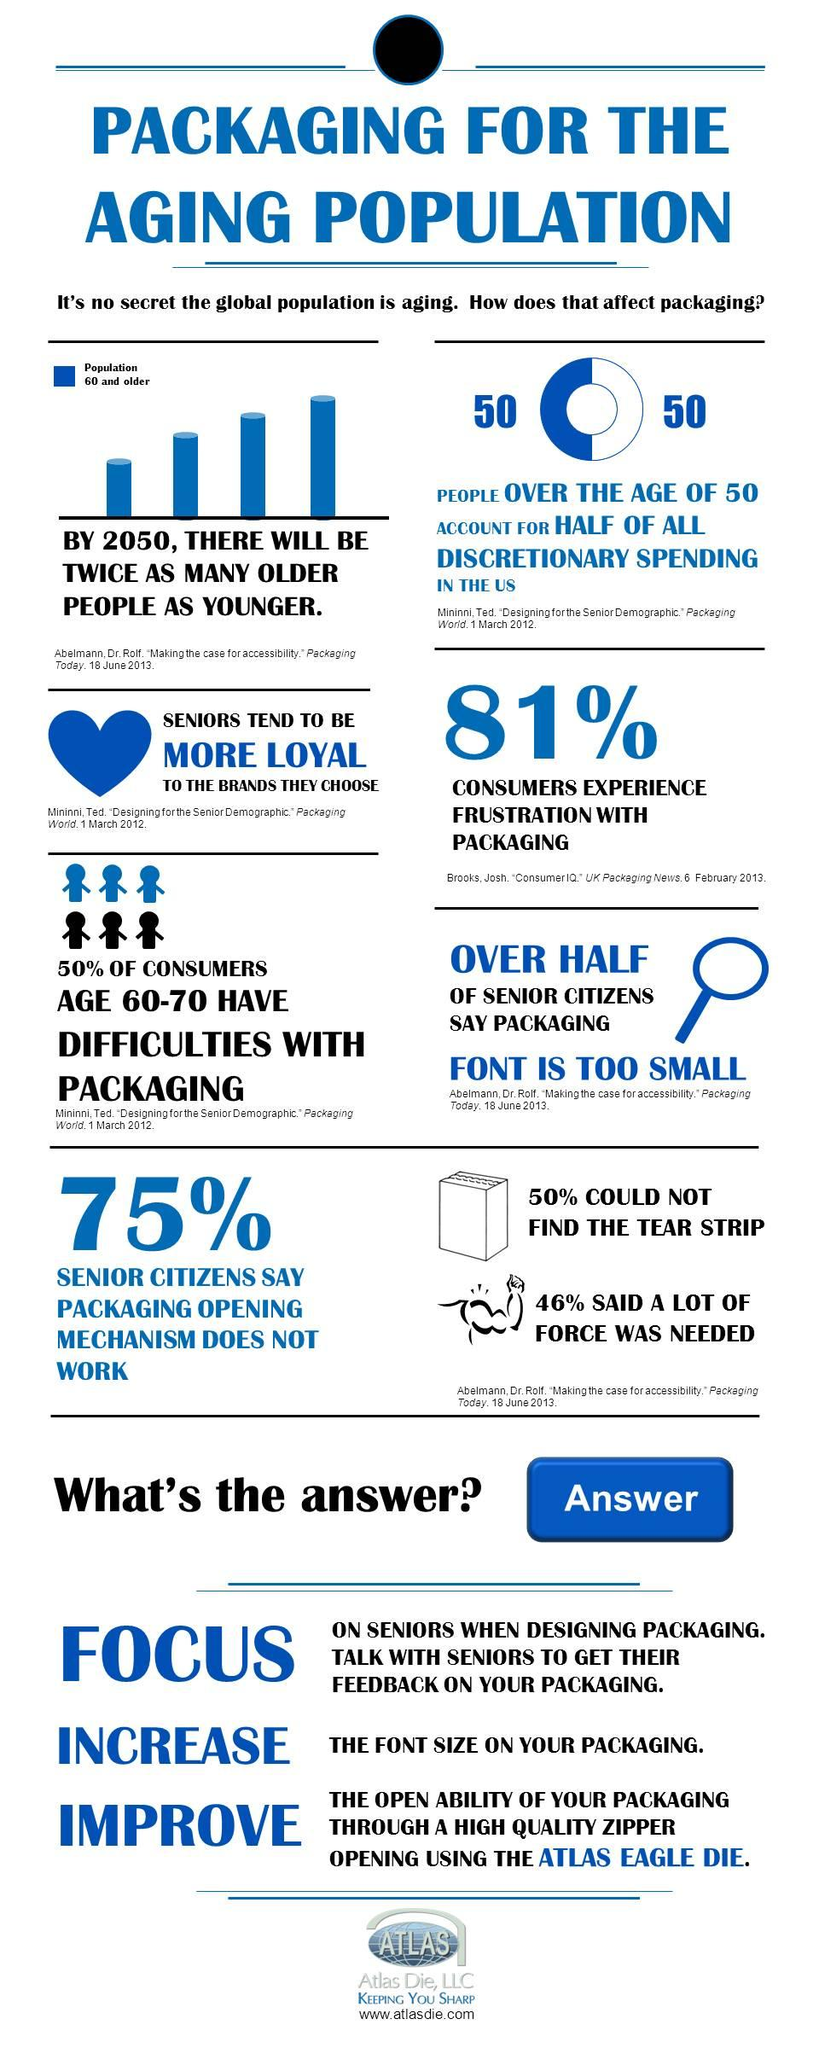Highlight a few significant elements in this photo. The elderly age group of 60-70 is facing the most difficulty with packaging. According to our survey, a significant 81% of customers are not satisfied with the outer covering of our product. A survey has found that 75% of senior individuals are experiencing difficulty in opening the outer cover of various products. 